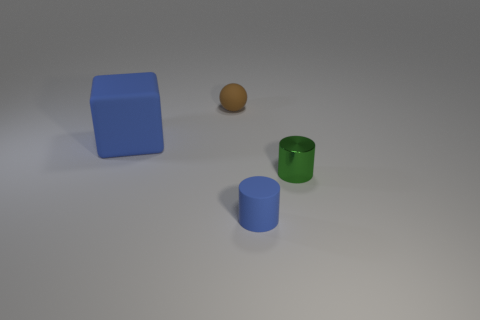Is there any other thing that is the same size as the matte cube?
Give a very brief answer. No. Are there any other things that are the same shape as the tiny blue thing?
Offer a very short reply. Yes. Are there fewer blue matte spheres than metal objects?
Your answer should be very brief. Yes. The tiny thing that is behind the blue cylinder and right of the tiny brown sphere is made of what material?
Your response must be concise. Metal. There is a matte object that is to the left of the sphere; are there any small spheres on the right side of it?
Ensure brevity in your answer.  Yes. What number of objects are either brown rubber balls or small red metallic cubes?
Offer a very short reply. 1. There is a small object that is in front of the matte sphere and behind the blue rubber cylinder; what shape is it?
Ensure brevity in your answer.  Cylinder. Is the material of the blue thing left of the brown rubber sphere the same as the brown thing?
Offer a terse response. Yes. How many things are gray metallic cubes or tiny brown matte objects behind the small metal object?
Keep it short and to the point. 1. What color is the small object that is the same material as the ball?
Make the answer very short. Blue. 